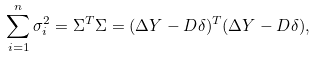<formula> <loc_0><loc_0><loc_500><loc_500>\sum _ { i = 1 } ^ { n } \sigma _ { i } ^ { 2 } = \Sigma ^ { T } \Sigma = ( \Delta Y - D \delta ) ^ { T } ( \Delta Y - D \delta ) ,</formula> 